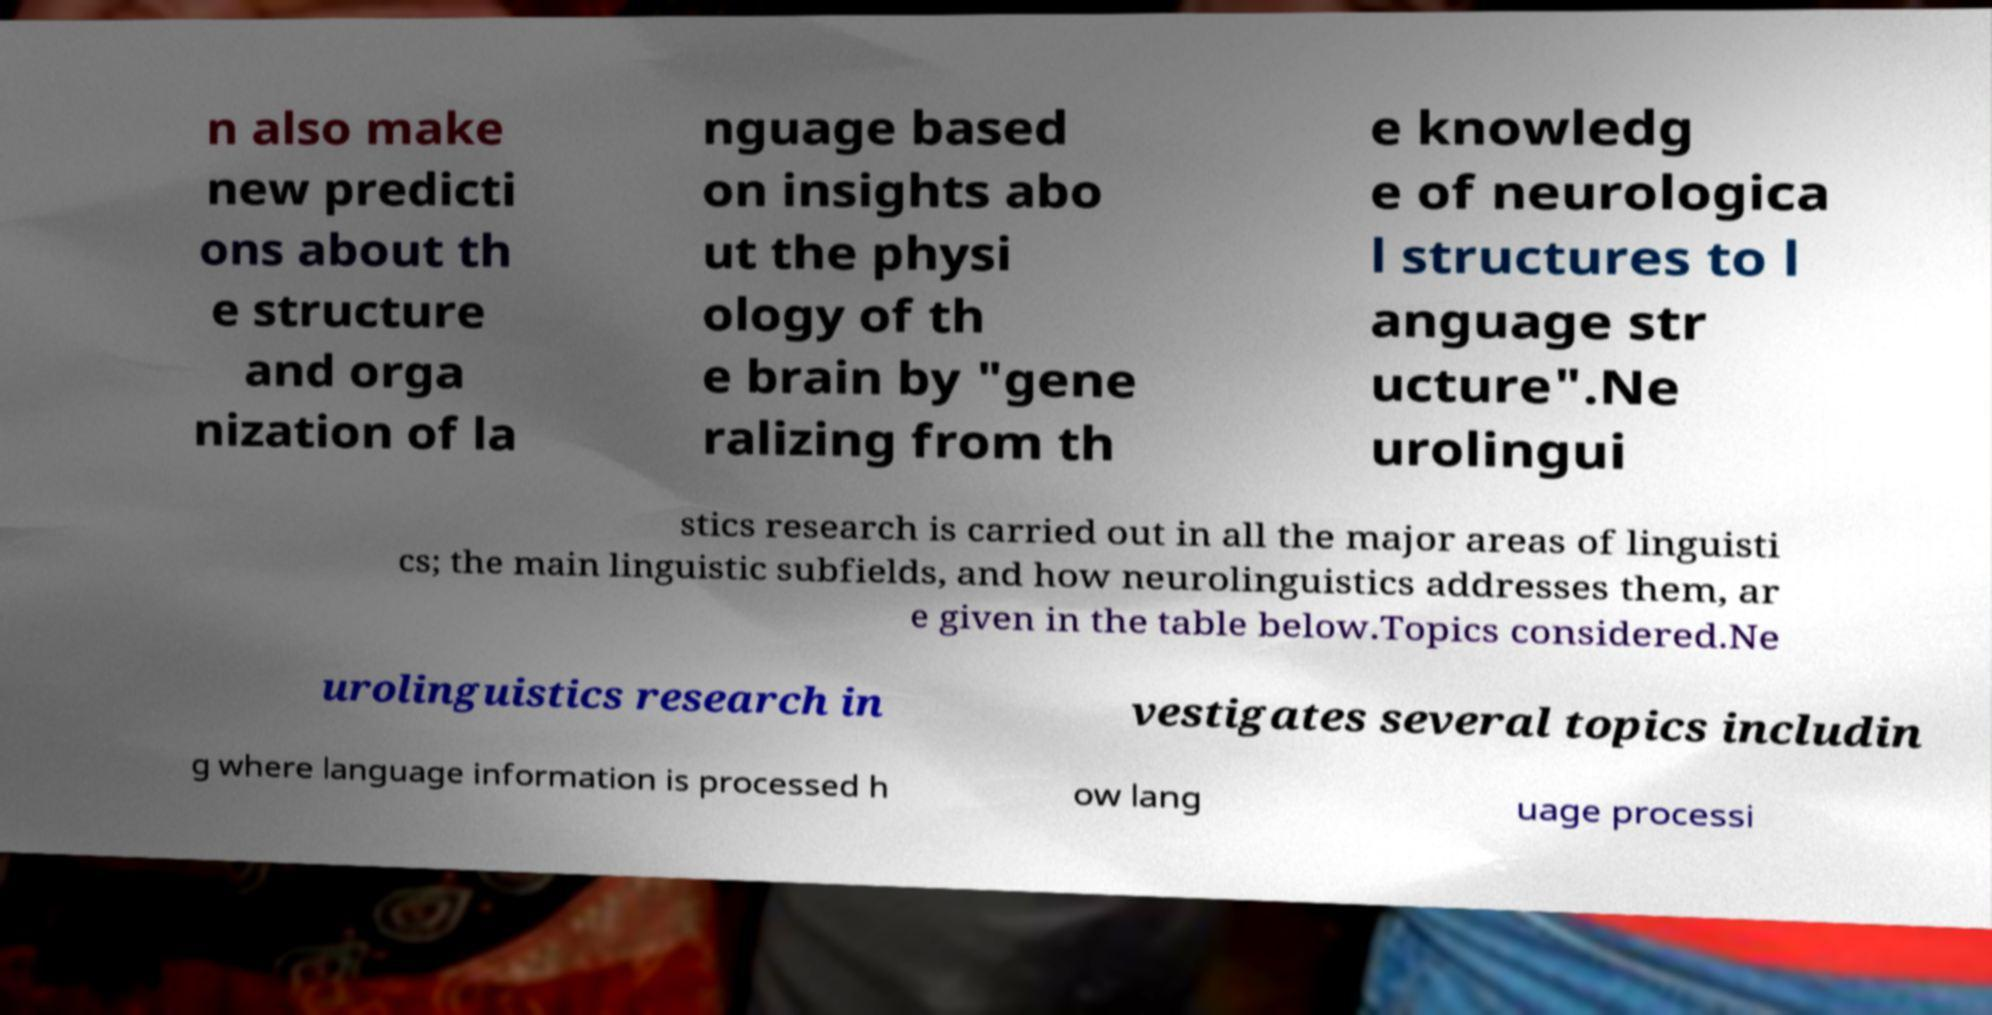I need the written content from this picture converted into text. Can you do that? n also make new predicti ons about th e structure and orga nization of la nguage based on insights abo ut the physi ology of th e brain by "gene ralizing from th e knowledg e of neurologica l structures to l anguage str ucture".Ne urolingui stics research is carried out in all the major areas of linguisti cs; the main linguistic subfields, and how neurolinguistics addresses them, ar e given in the table below.Topics considered.Ne urolinguistics research in vestigates several topics includin g where language information is processed h ow lang uage processi 